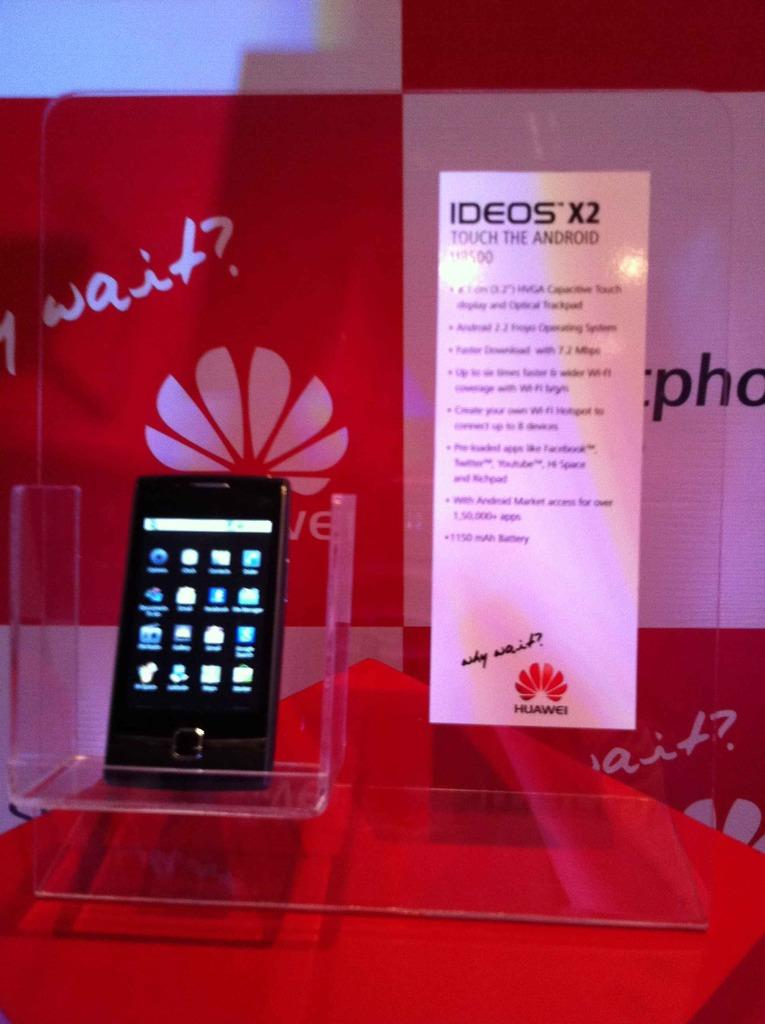<image>
Present a compact description of the photo's key features. The new IDEOS X2 cell phone is on display at a Huawei table. 